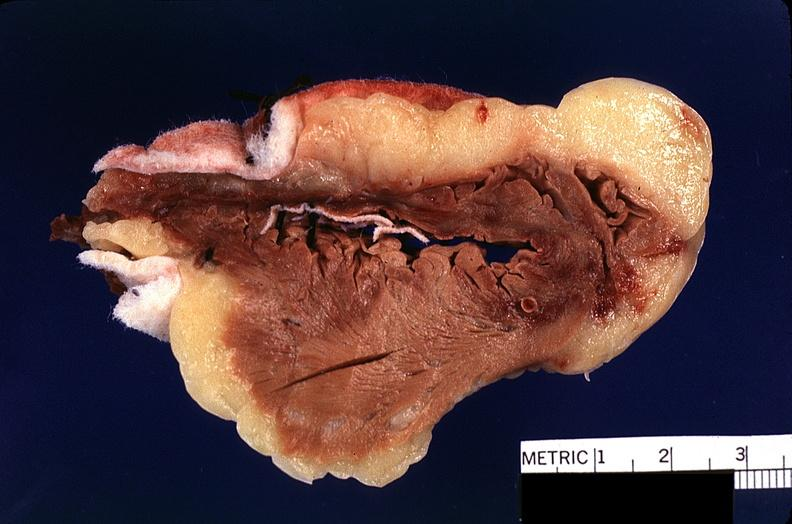what does this image show?
Answer the question using a single word or phrase. Heart 